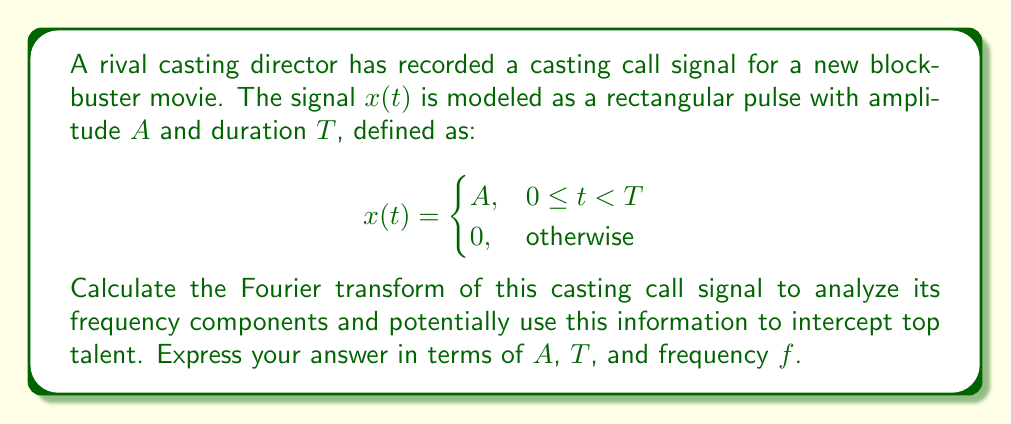Can you solve this math problem? To calculate the Fourier transform of the given signal, we'll follow these steps:

1) The Fourier transform is defined as:

   $$X(f) = \int_{-\infty}^{\infty} x(t) e^{-j2\pi ft} dt$$

2) Given our signal $x(t)$, we only need to integrate from 0 to T:

   $$X(f) = \int_{0}^{T} A e^{-j2\pi ft} dt$$

3) Evaluate the integral:

   $$X(f) = A \left[ \frac{e^{-j2\pi ft}}{-j2\pi f} \right]_{0}^{T}$$

4) Substitute the limits:

   $$X(f) = A \left( \frac{e^{-j2\pi fT}}{-j2\pi f} - \frac{1}{-j2\pi f} \right)$$

5) Find a common denominator:

   $$X(f) = \frac{A}{-j2\pi f} (e^{-j2\pi fT} - 1)$$

6) Multiply by $\frac{e^{j\pi fT}}{e^{j\pi fT}}$ to simplify:

   $$X(f) = \frac{A}{-j2\pi f} (e^{-j\pi fT} - e^{j\pi fT}) e^{-j\pi fT}$$

7) Recognize the difference of exponentials as twice the sine:

   $$X(f) = \frac{A}{-j2\pi f} (-2j\sin(\pi fT)) e^{-j\pi fT}$$

8) Simplify:

   $$X(f) = AT \frac{\sin(\pi fT)}{\pi fT} e^{-j\pi fT}$$

This is the final form of the Fourier transform of the casting call signal.
Answer: $$X(f) = AT \frac{\sin(\pi fT)}{\pi fT} e^{-j\pi fT}$$ 